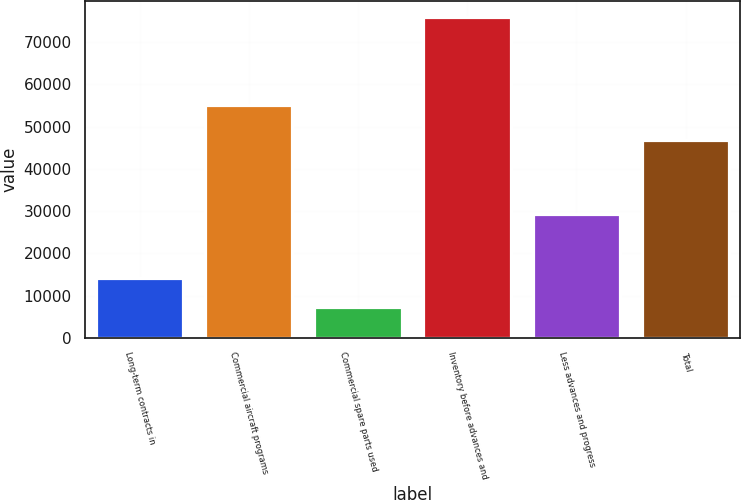Convert chart. <chart><loc_0><loc_0><loc_500><loc_500><bar_chart><fcel>Long-term contracts in<fcel>Commercial aircraft programs<fcel>Commercial spare parts used<fcel>Inventory before advances and<fcel>Less advances and progress<fcel>Total<nl><fcel>14281.1<fcel>55220<fcel>7421<fcel>76022<fcel>29266<fcel>46756<nl></chart> 